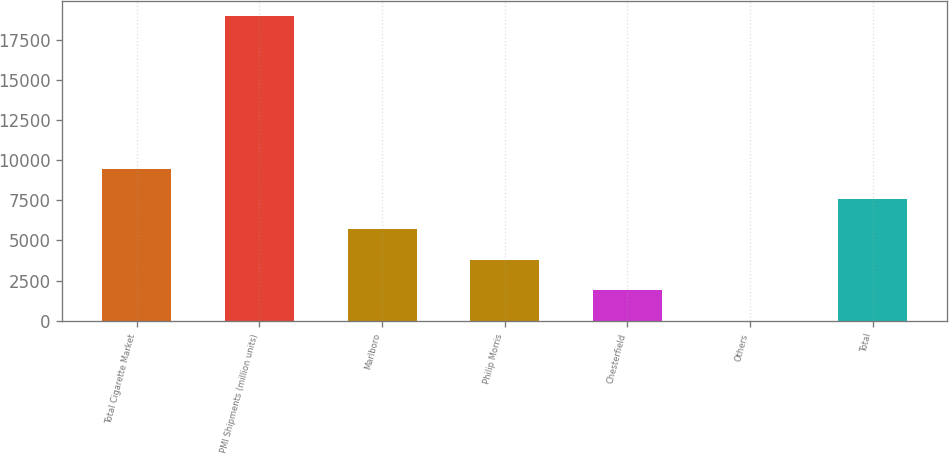Convert chart to OTSL. <chart><loc_0><loc_0><loc_500><loc_500><bar_chart><fcel>Total Cigarette Market<fcel>PMI Shipments (million units)<fcel>Marlboro<fcel>Philip Morris<fcel>Chesterfield<fcel>Others<fcel>Total<nl><fcel>9472.95<fcel>18943<fcel>5684.93<fcel>3790.92<fcel>1896.91<fcel>2.9<fcel>7578.94<nl></chart> 